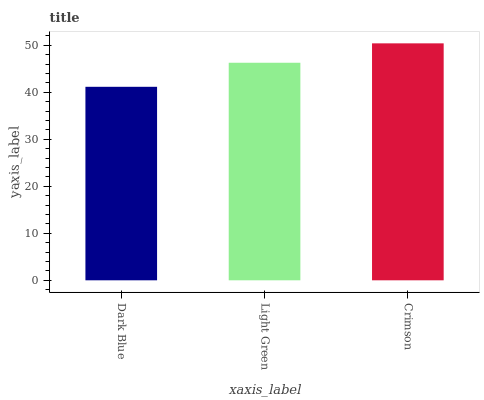Is Dark Blue the minimum?
Answer yes or no. Yes. Is Crimson the maximum?
Answer yes or no. Yes. Is Light Green the minimum?
Answer yes or no. No. Is Light Green the maximum?
Answer yes or no. No. Is Light Green greater than Dark Blue?
Answer yes or no. Yes. Is Dark Blue less than Light Green?
Answer yes or no. Yes. Is Dark Blue greater than Light Green?
Answer yes or no. No. Is Light Green less than Dark Blue?
Answer yes or no. No. Is Light Green the high median?
Answer yes or no. Yes. Is Light Green the low median?
Answer yes or no. Yes. Is Crimson the high median?
Answer yes or no. No. Is Crimson the low median?
Answer yes or no. No. 